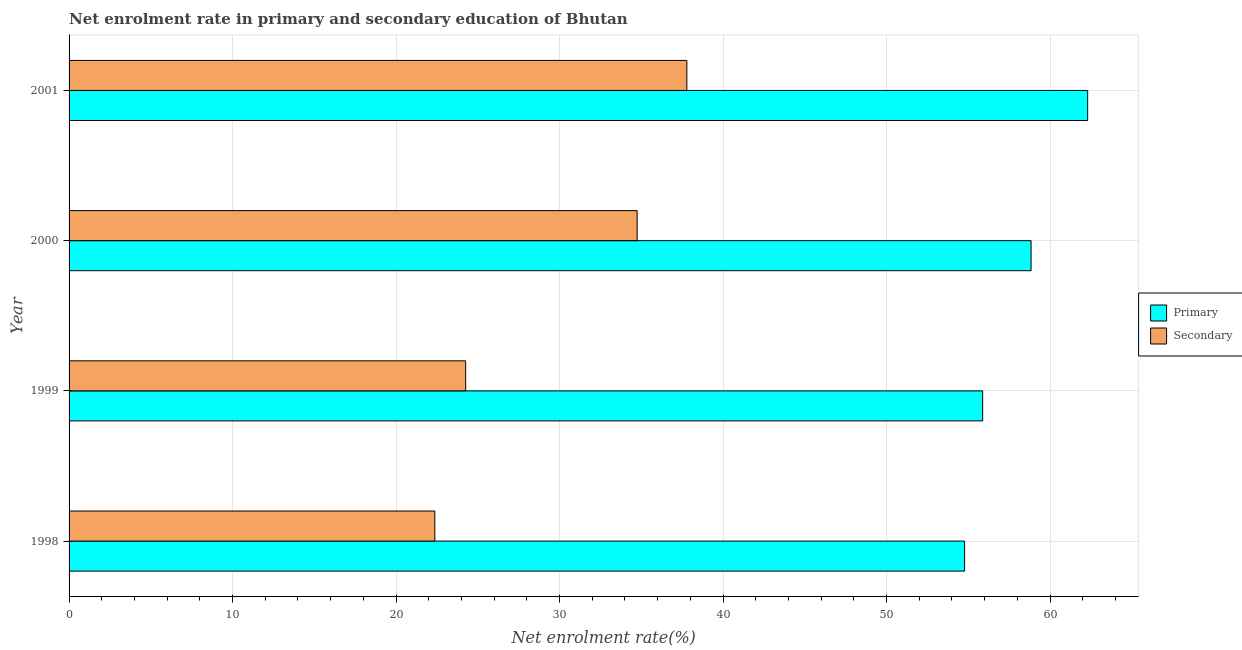How many different coloured bars are there?
Keep it short and to the point. 2. How many groups of bars are there?
Provide a succinct answer. 4. What is the enrollment rate in secondary education in 2000?
Give a very brief answer. 34.75. Across all years, what is the maximum enrollment rate in primary education?
Your response must be concise. 62.3. Across all years, what is the minimum enrollment rate in primary education?
Give a very brief answer. 54.77. In which year was the enrollment rate in primary education maximum?
Your response must be concise. 2001. In which year was the enrollment rate in primary education minimum?
Offer a terse response. 1998. What is the total enrollment rate in primary education in the graph?
Ensure brevity in your answer.  231.79. What is the difference between the enrollment rate in secondary education in 2000 and that in 2001?
Make the answer very short. -3.04. What is the difference between the enrollment rate in primary education in 2000 and the enrollment rate in secondary education in 2001?
Provide a short and direct response. 21.05. What is the average enrollment rate in primary education per year?
Keep it short and to the point. 57.95. In the year 2000, what is the difference between the enrollment rate in secondary education and enrollment rate in primary education?
Ensure brevity in your answer.  -24.09. Is the enrollment rate in secondary education in 1998 less than that in 1999?
Make the answer very short. Yes. What is the difference between the highest and the second highest enrollment rate in secondary education?
Offer a terse response. 3.04. What is the difference between the highest and the lowest enrollment rate in secondary education?
Your answer should be compact. 15.42. What does the 1st bar from the top in 2000 represents?
Give a very brief answer. Secondary. What does the 2nd bar from the bottom in 1998 represents?
Your answer should be very brief. Secondary. How many bars are there?
Provide a succinct answer. 8. Are the values on the major ticks of X-axis written in scientific E-notation?
Your answer should be compact. No. Where does the legend appear in the graph?
Your answer should be very brief. Center right. How many legend labels are there?
Make the answer very short. 2. What is the title of the graph?
Ensure brevity in your answer.  Net enrolment rate in primary and secondary education of Bhutan. Does "Agricultural land" appear as one of the legend labels in the graph?
Your answer should be very brief. No. What is the label or title of the X-axis?
Your answer should be very brief. Net enrolment rate(%). What is the Net enrolment rate(%) of Primary in 1998?
Your answer should be very brief. 54.77. What is the Net enrolment rate(%) in Secondary in 1998?
Offer a terse response. 22.37. What is the Net enrolment rate(%) of Primary in 1999?
Your answer should be compact. 55.88. What is the Net enrolment rate(%) in Secondary in 1999?
Make the answer very short. 24.26. What is the Net enrolment rate(%) in Primary in 2000?
Your answer should be compact. 58.84. What is the Net enrolment rate(%) of Secondary in 2000?
Your answer should be compact. 34.75. What is the Net enrolment rate(%) of Primary in 2001?
Provide a short and direct response. 62.3. What is the Net enrolment rate(%) of Secondary in 2001?
Offer a terse response. 37.79. Across all years, what is the maximum Net enrolment rate(%) of Primary?
Ensure brevity in your answer.  62.3. Across all years, what is the maximum Net enrolment rate(%) in Secondary?
Provide a succinct answer. 37.79. Across all years, what is the minimum Net enrolment rate(%) of Primary?
Give a very brief answer. 54.77. Across all years, what is the minimum Net enrolment rate(%) in Secondary?
Your response must be concise. 22.37. What is the total Net enrolment rate(%) in Primary in the graph?
Your answer should be very brief. 231.79. What is the total Net enrolment rate(%) in Secondary in the graph?
Give a very brief answer. 119.16. What is the difference between the Net enrolment rate(%) in Primary in 1998 and that in 1999?
Your answer should be compact. -1.1. What is the difference between the Net enrolment rate(%) in Secondary in 1998 and that in 1999?
Make the answer very short. -1.89. What is the difference between the Net enrolment rate(%) in Primary in 1998 and that in 2000?
Your answer should be compact. -4.07. What is the difference between the Net enrolment rate(%) of Secondary in 1998 and that in 2000?
Offer a very short reply. -12.38. What is the difference between the Net enrolment rate(%) of Primary in 1998 and that in 2001?
Offer a very short reply. -7.53. What is the difference between the Net enrolment rate(%) of Secondary in 1998 and that in 2001?
Provide a short and direct response. -15.42. What is the difference between the Net enrolment rate(%) in Primary in 1999 and that in 2000?
Ensure brevity in your answer.  -2.96. What is the difference between the Net enrolment rate(%) in Secondary in 1999 and that in 2000?
Your response must be concise. -10.49. What is the difference between the Net enrolment rate(%) in Primary in 1999 and that in 2001?
Ensure brevity in your answer.  -6.42. What is the difference between the Net enrolment rate(%) in Secondary in 1999 and that in 2001?
Keep it short and to the point. -13.53. What is the difference between the Net enrolment rate(%) in Primary in 2000 and that in 2001?
Ensure brevity in your answer.  -3.46. What is the difference between the Net enrolment rate(%) in Secondary in 2000 and that in 2001?
Ensure brevity in your answer.  -3.04. What is the difference between the Net enrolment rate(%) of Primary in 1998 and the Net enrolment rate(%) of Secondary in 1999?
Ensure brevity in your answer.  30.52. What is the difference between the Net enrolment rate(%) of Primary in 1998 and the Net enrolment rate(%) of Secondary in 2000?
Offer a very short reply. 20.03. What is the difference between the Net enrolment rate(%) in Primary in 1998 and the Net enrolment rate(%) in Secondary in 2001?
Provide a short and direct response. 16.99. What is the difference between the Net enrolment rate(%) in Primary in 1999 and the Net enrolment rate(%) in Secondary in 2000?
Ensure brevity in your answer.  21.13. What is the difference between the Net enrolment rate(%) in Primary in 1999 and the Net enrolment rate(%) in Secondary in 2001?
Offer a terse response. 18.09. What is the difference between the Net enrolment rate(%) in Primary in 2000 and the Net enrolment rate(%) in Secondary in 2001?
Your response must be concise. 21.05. What is the average Net enrolment rate(%) in Primary per year?
Make the answer very short. 57.95. What is the average Net enrolment rate(%) in Secondary per year?
Keep it short and to the point. 29.79. In the year 1998, what is the difference between the Net enrolment rate(%) of Primary and Net enrolment rate(%) of Secondary?
Provide a succinct answer. 32.4. In the year 1999, what is the difference between the Net enrolment rate(%) in Primary and Net enrolment rate(%) in Secondary?
Offer a very short reply. 31.62. In the year 2000, what is the difference between the Net enrolment rate(%) of Primary and Net enrolment rate(%) of Secondary?
Make the answer very short. 24.09. In the year 2001, what is the difference between the Net enrolment rate(%) in Primary and Net enrolment rate(%) in Secondary?
Your answer should be very brief. 24.51. What is the ratio of the Net enrolment rate(%) in Primary in 1998 to that in 1999?
Offer a very short reply. 0.98. What is the ratio of the Net enrolment rate(%) in Secondary in 1998 to that in 1999?
Ensure brevity in your answer.  0.92. What is the ratio of the Net enrolment rate(%) in Primary in 1998 to that in 2000?
Ensure brevity in your answer.  0.93. What is the ratio of the Net enrolment rate(%) of Secondary in 1998 to that in 2000?
Offer a very short reply. 0.64. What is the ratio of the Net enrolment rate(%) in Primary in 1998 to that in 2001?
Provide a succinct answer. 0.88. What is the ratio of the Net enrolment rate(%) in Secondary in 1998 to that in 2001?
Your answer should be compact. 0.59. What is the ratio of the Net enrolment rate(%) in Primary in 1999 to that in 2000?
Provide a succinct answer. 0.95. What is the ratio of the Net enrolment rate(%) of Secondary in 1999 to that in 2000?
Your response must be concise. 0.7. What is the ratio of the Net enrolment rate(%) of Primary in 1999 to that in 2001?
Your response must be concise. 0.9. What is the ratio of the Net enrolment rate(%) in Secondary in 1999 to that in 2001?
Your response must be concise. 0.64. What is the ratio of the Net enrolment rate(%) in Secondary in 2000 to that in 2001?
Make the answer very short. 0.92. What is the difference between the highest and the second highest Net enrolment rate(%) of Primary?
Provide a short and direct response. 3.46. What is the difference between the highest and the second highest Net enrolment rate(%) in Secondary?
Your response must be concise. 3.04. What is the difference between the highest and the lowest Net enrolment rate(%) in Primary?
Give a very brief answer. 7.53. What is the difference between the highest and the lowest Net enrolment rate(%) of Secondary?
Your response must be concise. 15.42. 